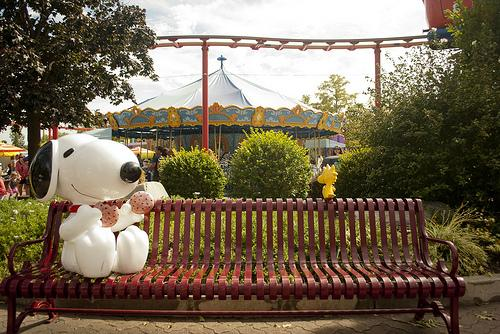Write a brief description of the scenery in the image. The image features a carousel with a blue and yellow tent, a roller coaster, and Snoopy sitting on a red bench with cookies. Describe a scene containing an amusement park ride and a character. Snoopy sits on a red bench, holding cookies, with a carousel and a red roller coaster in the background. What is the most striking element in the image and what is its color? The red roller coaster car on tracks is a prominent element in the image. List three attractions visible in the image. The image displays a carousel, a roller coaster, and a statue of Snoopy with cookies. Describe the location and appearance of the bench in the image. The red metal bench is on a brick pathway and Snoopy sits on it with cookies in his hands. Mention an object in the foreground and an object in the background of the image. In the foreground, there are green bushes, and in the background, there is a carousel with a blue and yellow tent. Identify the main components of the amusement park theme in the image. The amusement park theme includes a carousel, a red roller coaster, and Snoopy as the main character. Point out three major objects present in the image and their colors. The carousel has a blue and yellow tent, the roller coaster track is red, and there is a statue of a white dog named Snoopy. What is the position of the main character and his surroundings? Snoopy is sitting on a red bench in front of the green bushes, which are in front of the carousel. Mention the central character in the image and their activity. Snoopy, a white dog, is sitting and holding two chocolate chip cookies in his hands. 